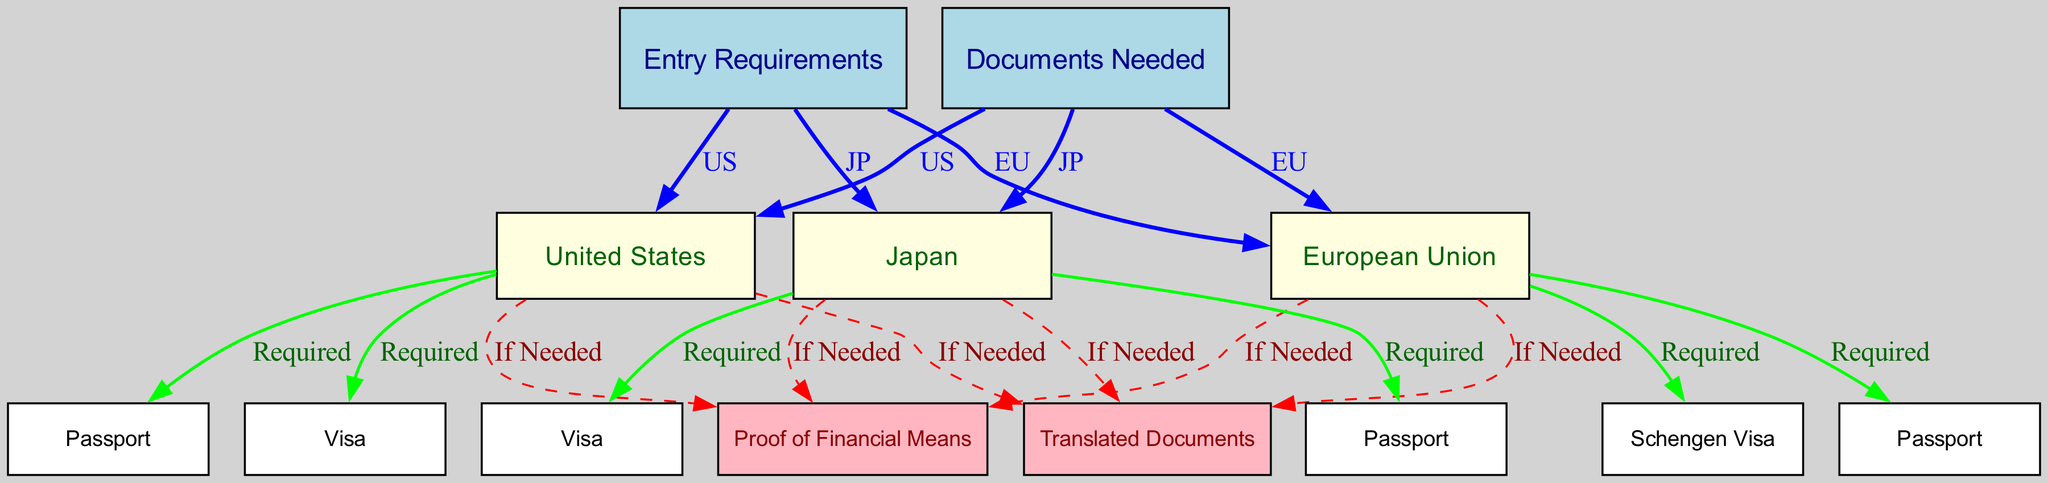What are the entry requirements for the United States? The entry requirements as listed under "Entry Requirements" include "United States," which is shown as a connected node.
Answer: United States How many documents are needed for entry to Japan? Under "Documents Needed," the diagram specifies the entry requirements for Japan, which includes “Visa” and “Passport.” Connecting these nodes counts as two documents.
Answer: Two What is required for entry into the European Union? The diagram specifies “Schengen Visa” and “Passport” under the "European Union" entry requirements, indicating both need to be obtained for entry.
Answer: Schengen Visa and Passport What type of visa is required for entry into the United States? According to the diagram under "United States" requirements, a "Visa" is specified as "Required". Thus, a visa is necessary for entry into the US.
Answer: Visa What additional documents might be needed for the United States? The diagram states that “Translated Documents” and “Proof of Financial Means” are included as "If Needed" under the United States requirements, suggesting they may be necessary depending on individual circumstances.
Answer: Translated Documents and Proof of Financial Means Which countries have specific entry requirements listed in this diagram? The diagram has entries listed for the United States, European Union, and Japan under the "Entry Requirements" section, showing that these three countries have specified requirements.
Answer: United States, European Union, Japan What color indicates documents that are required in the diagram? The edges connecting “Entry Requirements” nodes to “Documents Needed” nodes that are labeled "Required" are colored green, representing mandatory documents for entry.
Answer: Green How many edges connect to the "Documents Needed" node? By examining the connections, the "Documents Needed" node shows three edges leading to corresponding country requirements, meaning three edges connect to it.
Answer: Three 